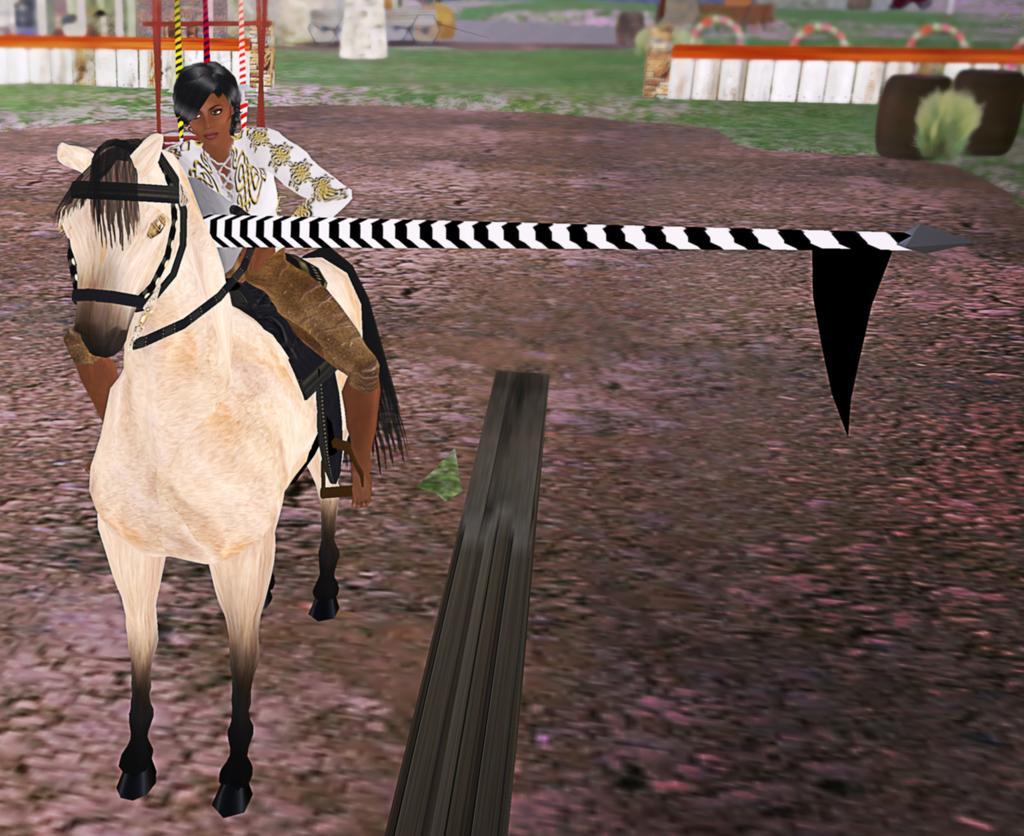Please provide a concise description of this image. This is an animated image and in this picture we can see a woman sitting on a horse on the ground, flag, fences, rods and some objects. 